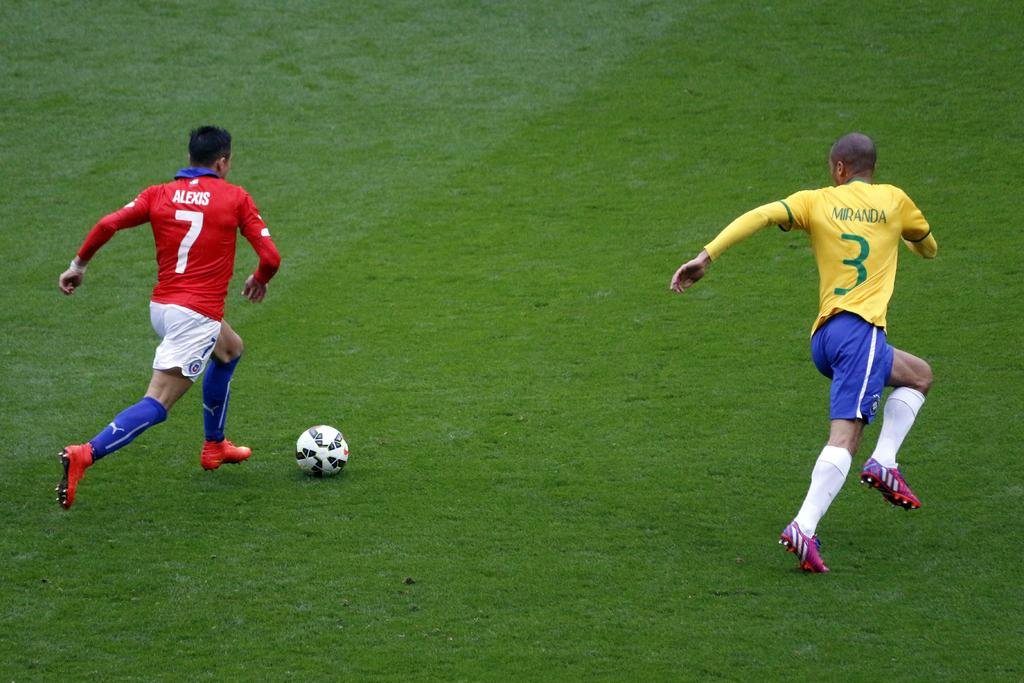<image>
Describe the image concisely. A soccer player with a red shirt with the number 7 and his name - Alexis printed on it and another soccer player with a yellow t-shirt. 